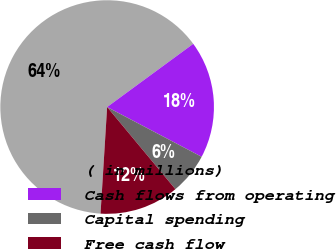Convert chart. <chart><loc_0><loc_0><loc_500><loc_500><pie_chart><fcel>( in millions)<fcel>Cash flows from operating<fcel>Capital spending<fcel>Free cash flow<nl><fcel>63.94%<fcel>17.79%<fcel>6.25%<fcel>12.02%<nl></chart> 